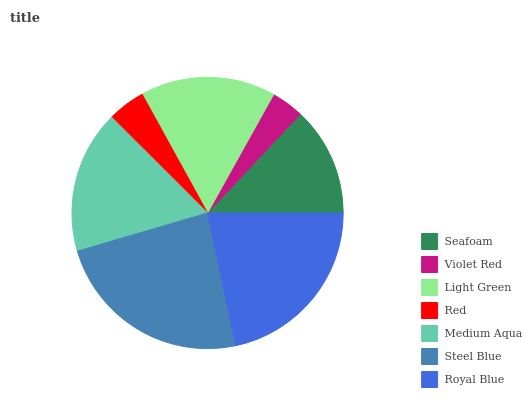Is Violet Red the minimum?
Answer yes or no. Yes. Is Steel Blue the maximum?
Answer yes or no. Yes. Is Light Green the minimum?
Answer yes or no. No. Is Light Green the maximum?
Answer yes or no. No. Is Light Green greater than Violet Red?
Answer yes or no. Yes. Is Violet Red less than Light Green?
Answer yes or no. Yes. Is Violet Red greater than Light Green?
Answer yes or no. No. Is Light Green less than Violet Red?
Answer yes or no. No. Is Light Green the high median?
Answer yes or no. Yes. Is Light Green the low median?
Answer yes or no. Yes. Is Medium Aqua the high median?
Answer yes or no. No. Is Steel Blue the low median?
Answer yes or no. No. 